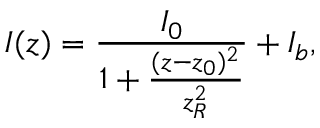Convert formula to latex. <formula><loc_0><loc_0><loc_500><loc_500>I ( z ) = \frac { I _ { 0 } } { 1 + \frac { ( z - z _ { 0 } ) ^ { 2 } } { z _ { R } ^ { 2 } } } + I _ { b } ,</formula> 